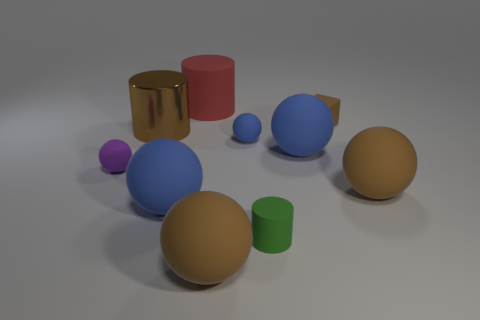What is the texture of the objects, and does it vary among them? The objects display different textures. The yellow ball and the red objects have a matte finish, reducing glare and reflection, while the blue objects, especially the large sphere, and the gold cylinder show a shiny, reflective texture. Is there a sense of harmony or balance in how the objects are arranged? The arrangement of objects creates a visually pleasing balance, with objects varying in size, color, and texture, carefully placed to form a cohesive composition that draws the viewer's eye across the scene. 